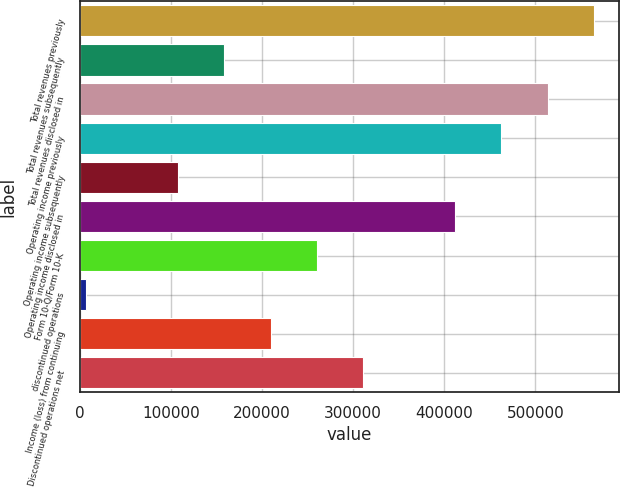Convert chart. <chart><loc_0><loc_0><loc_500><loc_500><bar_chart><fcel>Total revenues previously<fcel>Total revenues subsequently<fcel>Total revenues disclosed in<fcel>Operating income previously<fcel>Operating income subsequently<fcel>Operating income disclosed in<fcel>Form 10-Q/Form 10-K<fcel>discontinued operations<fcel>Income (loss) from continuing<fcel>Discontinued operations net<nl><fcel>563920<fcel>158821<fcel>513283<fcel>462646<fcel>108184<fcel>412008<fcel>260096<fcel>6909<fcel>209459<fcel>310733<nl></chart> 